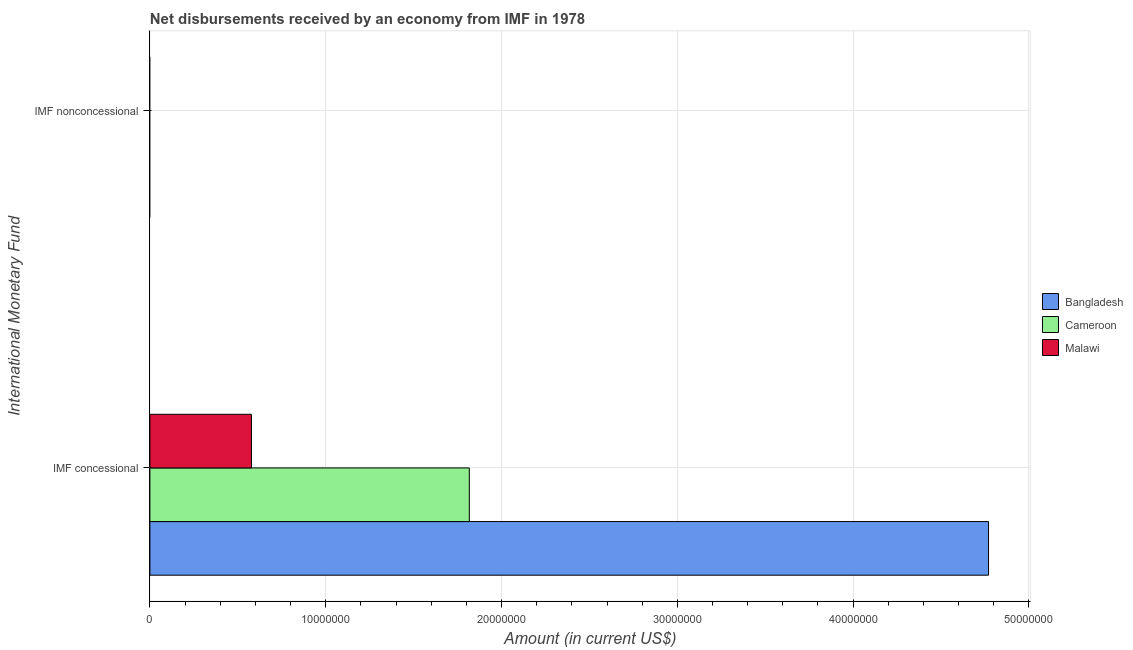How many different coloured bars are there?
Provide a succinct answer. 3. Are the number of bars per tick equal to the number of legend labels?
Your response must be concise. No. Are the number of bars on each tick of the Y-axis equal?
Your response must be concise. No. How many bars are there on the 2nd tick from the bottom?
Make the answer very short. 0. What is the label of the 2nd group of bars from the top?
Your answer should be compact. IMF concessional. What is the total net concessional disbursements from imf in the graph?
Provide a succinct answer. 7.16e+07. What is the difference between the net concessional disbursements from imf in Bangladesh and that in Malawi?
Offer a terse response. 4.19e+07. What is the difference between the net non concessional disbursements from imf in Bangladesh and the net concessional disbursements from imf in Cameroon?
Offer a very short reply. -1.82e+07. In how many countries, is the net non concessional disbursements from imf greater than 24000000 US$?
Give a very brief answer. 0. What is the ratio of the net concessional disbursements from imf in Malawi to that in Bangladesh?
Offer a very short reply. 0.12. In how many countries, is the net concessional disbursements from imf greater than the average net concessional disbursements from imf taken over all countries?
Your answer should be very brief. 1. How many bars are there?
Offer a terse response. 3. How many countries are there in the graph?
Keep it short and to the point. 3. What is the difference between two consecutive major ticks on the X-axis?
Make the answer very short. 1.00e+07. Does the graph contain any zero values?
Provide a short and direct response. Yes. Where does the legend appear in the graph?
Provide a short and direct response. Center right. How many legend labels are there?
Your response must be concise. 3. How are the legend labels stacked?
Your answer should be very brief. Vertical. What is the title of the graph?
Your response must be concise. Net disbursements received by an economy from IMF in 1978. Does "Chad" appear as one of the legend labels in the graph?
Ensure brevity in your answer.  No. What is the label or title of the Y-axis?
Your response must be concise. International Monetary Fund. What is the Amount (in current US$) of Bangladesh in IMF concessional?
Offer a terse response. 4.77e+07. What is the Amount (in current US$) in Cameroon in IMF concessional?
Offer a terse response. 1.82e+07. What is the Amount (in current US$) in Malawi in IMF concessional?
Offer a terse response. 5.78e+06. What is the Amount (in current US$) in Cameroon in IMF nonconcessional?
Keep it short and to the point. 0. Across all International Monetary Fund, what is the maximum Amount (in current US$) in Bangladesh?
Offer a very short reply. 4.77e+07. Across all International Monetary Fund, what is the maximum Amount (in current US$) of Cameroon?
Provide a succinct answer. 1.82e+07. Across all International Monetary Fund, what is the maximum Amount (in current US$) in Malawi?
Offer a terse response. 5.78e+06. Across all International Monetary Fund, what is the minimum Amount (in current US$) in Malawi?
Your answer should be very brief. 0. What is the total Amount (in current US$) in Bangladesh in the graph?
Make the answer very short. 4.77e+07. What is the total Amount (in current US$) of Cameroon in the graph?
Give a very brief answer. 1.82e+07. What is the total Amount (in current US$) in Malawi in the graph?
Your answer should be compact. 5.78e+06. What is the average Amount (in current US$) of Bangladesh per International Monetary Fund?
Ensure brevity in your answer.  2.38e+07. What is the average Amount (in current US$) in Cameroon per International Monetary Fund?
Offer a very short reply. 9.08e+06. What is the average Amount (in current US$) of Malawi per International Monetary Fund?
Make the answer very short. 2.89e+06. What is the difference between the Amount (in current US$) of Bangladesh and Amount (in current US$) of Cameroon in IMF concessional?
Provide a short and direct response. 2.95e+07. What is the difference between the Amount (in current US$) of Bangladesh and Amount (in current US$) of Malawi in IMF concessional?
Keep it short and to the point. 4.19e+07. What is the difference between the Amount (in current US$) of Cameroon and Amount (in current US$) of Malawi in IMF concessional?
Provide a succinct answer. 1.24e+07. What is the difference between the highest and the lowest Amount (in current US$) in Bangladesh?
Offer a terse response. 4.77e+07. What is the difference between the highest and the lowest Amount (in current US$) in Cameroon?
Ensure brevity in your answer.  1.82e+07. What is the difference between the highest and the lowest Amount (in current US$) of Malawi?
Your answer should be compact. 5.78e+06. 